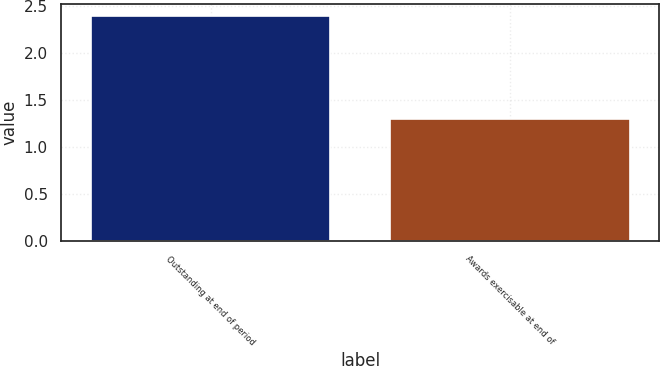<chart> <loc_0><loc_0><loc_500><loc_500><bar_chart><fcel>Outstanding at end of period<fcel>Awards exercisable at end of<nl><fcel>2.4<fcel>1.3<nl></chart> 